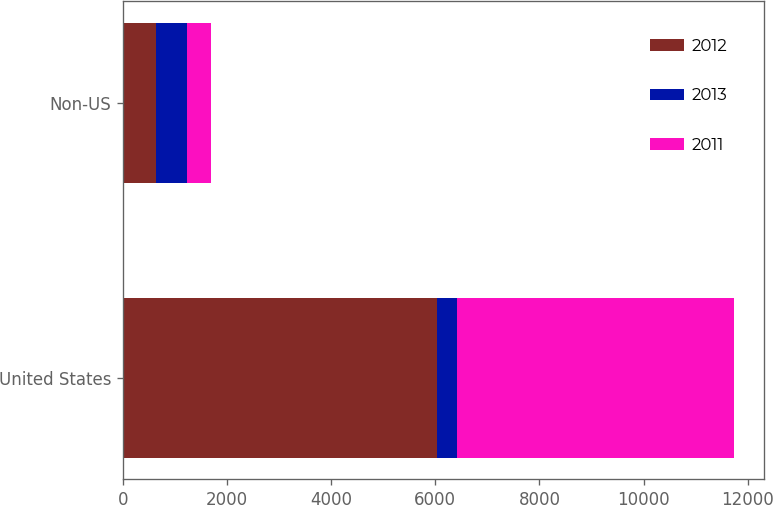Convert chart to OTSL. <chart><loc_0><loc_0><loc_500><loc_500><stacked_bar_chart><ecel><fcel>United States<fcel>Non-US<nl><fcel>2012<fcel>6040<fcel>634<nl><fcel>2013<fcel>384<fcel>590<nl><fcel>2011<fcel>5309<fcel>467<nl></chart> 